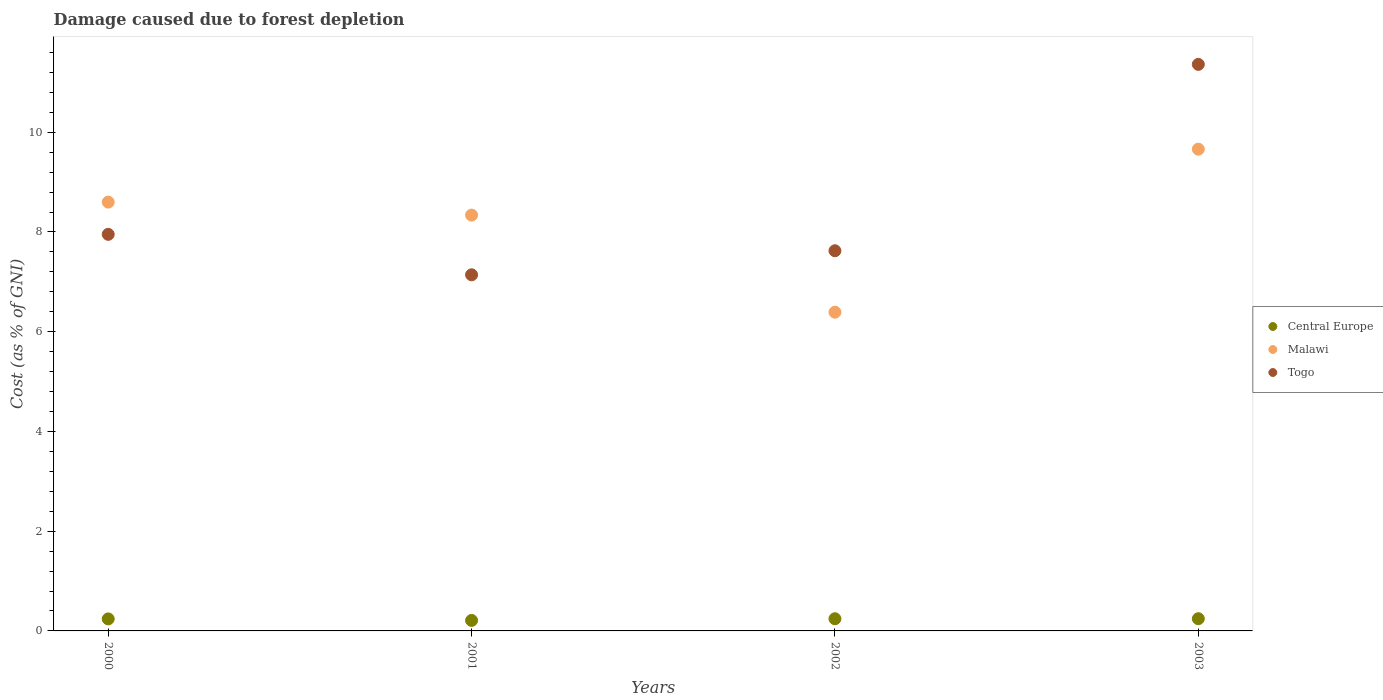Is the number of dotlines equal to the number of legend labels?
Your response must be concise. Yes. What is the cost of damage caused due to forest depletion in Central Europe in 2003?
Provide a succinct answer. 0.24. Across all years, what is the maximum cost of damage caused due to forest depletion in Togo?
Offer a very short reply. 11.36. Across all years, what is the minimum cost of damage caused due to forest depletion in Togo?
Make the answer very short. 7.14. In which year was the cost of damage caused due to forest depletion in Togo maximum?
Provide a succinct answer. 2003. What is the total cost of damage caused due to forest depletion in Malawi in the graph?
Ensure brevity in your answer.  32.99. What is the difference between the cost of damage caused due to forest depletion in Malawi in 2002 and that in 2003?
Offer a terse response. -3.27. What is the difference between the cost of damage caused due to forest depletion in Togo in 2003 and the cost of damage caused due to forest depletion in Central Europe in 2001?
Ensure brevity in your answer.  11.15. What is the average cost of damage caused due to forest depletion in Malawi per year?
Your answer should be compact. 8.25. In the year 2000, what is the difference between the cost of damage caused due to forest depletion in Malawi and cost of damage caused due to forest depletion in Central Europe?
Offer a terse response. 8.36. What is the ratio of the cost of damage caused due to forest depletion in Togo in 2000 to that in 2002?
Offer a terse response. 1.04. Is the difference between the cost of damage caused due to forest depletion in Malawi in 2000 and 2002 greater than the difference between the cost of damage caused due to forest depletion in Central Europe in 2000 and 2002?
Give a very brief answer. Yes. What is the difference between the highest and the second highest cost of damage caused due to forest depletion in Togo?
Your response must be concise. 3.41. What is the difference between the highest and the lowest cost of damage caused due to forest depletion in Togo?
Offer a very short reply. 4.22. In how many years, is the cost of damage caused due to forest depletion in Togo greater than the average cost of damage caused due to forest depletion in Togo taken over all years?
Provide a succinct answer. 1. Is the sum of the cost of damage caused due to forest depletion in Togo in 2002 and 2003 greater than the maximum cost of damage caused due to forest depletion in Malawi across all years?
Your answer should be very brief. Yes. Is the cost of damage caused due to forest depletion in Togo strictly greater than the cost of damage caused due to forest depletion in Malawi over the years?
Offer a terse response. No. Is the cost of damage caused due to forest depletion in Central Europe strictly less than the cost of damage caused due to forest depletion in Malawi over the years?
Provide a short and direct response. Yes. How many dotlines are there?
Your response must be concise. 3. How many years are there in the graph?
Your answer should be compact. 4. What is the difference between two consecutive major ticks on the Y-axis?
Ensure brevity in your answer.  2. Where does the legend appear in the graph?
Ensure brevity in your answer.  Center right. How many legend labels are there?
Make the answer very short. 3. How are the legend labels stacked?
Provide a short and direct response. Vertical. What is the title of the graph?
Keep it short and to the point. Damage caused due to forest depletion. What is the label or title of the Y-axis?
Your answer should be very brief. Cost (as % of GNI). What is the Cost (as % of GNI) of Central Europe in 2000?
Offer a terse response. 0.24. What is the Cost (as % of GNI) in Malawi in 2000?
Your answer should be very brief. 8.6. What is the Cost (as % of GNI) of Togo in 2000?
Provide a succinct answer. 7.95. What is the Cost (as % of GNI) in Central Europe in 2001?
Your answer should be very brief. 0.21. What is the Cost (as % of GNI) in Malawi in 2001?
Your answer should be very brief. 8.34. What is the Cost (as % of GNI) of Togo in 2001?
Your answer should be compact. 7.14. What is the Cost (as % of GNI) of Central Europe in 2002?
Ensure brevity in your answer.  0.24. What is the Cost (as % of GNI) of Malawi in 2002?
Provide a short and direct response. 6.39. What is the Cost (as % of GNI) in Togo in 2002?
Give a very brief answer. 7.62. What is the Cost (as % of GNI) of Central Europe in 2003?
Your response must be concise. 0.24. What is the Cost (as % of GNI) in Malawi in 2003?
Give a very brief answer. 9.66. What is the Cost (as % of GNI) of Togo in 2003?
Offer a terse response. 11.36. Across all years, what is the maximum Cost (as % of GNI) of Central Europe?
Provide a succinct answer. 0.24. Across all years, what is the maximum Cost (as % of GNI) of Malawi?
Provide a short and direct response. 9.66. Across all years, what is the maximum Cost (as % of GNI) of Togo?
Give a very brief answer. 11.36. Across all years, what is the minimum Cost (as % of GNI) in Central Europe?
Your answer should be compact. 0.21. Across all years, what is the minimum Cost (as % of GNI) in Malawi?
Ensure brevity in your answer.  6.39. Across all years, what is the minimum Cost (as % of GNI) of Togo?
Offer a very short reply. 7.14. What is the total Cost (as % of GNI) in Central Europe in the graph?
Give a very brief answer. 0.94. What is the total Cost (as % of GNI) of Malawi in the graph?
Your answer should be compact. 32.99. What is the total Cost (as % of GNI) of Togo in the graph?
Give a very brief answer. 34.08. What is the difference between the Cost (as % of GNI) in Central Europe in 2000 and that in 2001?
Your response must be concise. 0.03. What is the difference between the Cost (as % of GNI) in Malawi in 2000 and that in 2001?
Provide a succinct answer. 0.26. What is the difference between the Cost (as % of GNI) in Togo in 2000 and that in 2001?
Offer a very short reply. 0.81. What is the difference between the Cost (as % of GNI) of Central Europe in 2000 and that in 2002?
Provide a succinct answer. -0. What is the difference between the Cost (as % of GNI) of Malawi in 2000 and that in 2002?
Your answer should be very brief. 2.21. What is the difference between the Cost (as % of GNI) of Togo in 2000 and that in 2002?
Provide a succinct answer. 0.33. What is the difference between the Cost (as % of GNI) in Central Europe in 2000 and that in 2003?
Your response must be concise. -0. What is the difference between the Cost (as % of GNI) of Malawi in 2000 and that in 2003?
Provide a short and direct response. -1.06. What is the difference between the Cost (as % of GNI) in Togo in 2000 and that in 2003?
Offer a very short reply. -3.41. What is the difference between the Cost (as % of GNI) in Central Europe in 2001 and that in 2002?
Give a very brief answer. -0.03. What is the difference between the Cost (as % of GNI) in Malawi in 2001 and that in 2002?
Make the answer very short. 1.95. What is the difference between the Cost (as % of GNI) of Togo in 2001 and that in 2002?
Ensure brevity in your answer.  -0.48. What is the difference between the Cost (as % of GNI) of Central Europe in 2001 and that in 2003?
Make the answer very short. -0.03. What is the difference between the Cost (as % of GNI) in Malawi in 2001 and that in 2003?
Keep it short and to the point. -1.32. What is the difference between the Cost (as % of GNI) in Togo in 2001 and that in 2003?
Ensure brevity in your answer.  -4.22. What is the difference between the Cost (as % of GNI) in Central Europe in 2002 and that in 2003?
Your answer should be very brief. -0. What is the difference between the Cost (as % of GNI) in Malawi in 2002 and that in 2003?
Your answer should be compact. -3.27. What is the difference between the Cost (as % of GNI) of Togo in 2002 and that in 2003?
Keep it short and to the point. -3.74. What is the difference between the Cost (as % of GNI) of Central Europe in 2000 and the Cost (as % of GNI) of Malawi in 2001?
Provide a short and direct response. -8.1. What is the difference between the Cost (as % of GNI) of Central Europe in 2000 and the Cost (as % of GNI) of Togo in 2001?
Offer a very short reply. -6.9. What is the difference between the Cost (as % of GNI) of Malawi in 2000 and the Cost (as % of GNI) of Togo in 2001?
Your answer should be very brief. 1.46. What is the difference between the Cost (as % of GNI) of Central Europe in 2000 and the Cost (as % of GNI) of Malawi in 2002?
Offer a terse response. -6.15. What is the difference between the Cost (as % of GNI) in Central Europe in 2000 and the Cost (as % of GNI) in Togo in 2002?
Give a very brief answer. -7.38. What is the difference between the Cost (as % of GNI) in Malawi in 2000 and the Cost (as % of GNI) in Togo in 2002?
Offer a terse response. 0.98. What is the difference between the Cost (as % of GNI) of Central Europe in 2000 and the Cost (as % of GNI) of Malawi in 2003?
Offer a terse response. -9.42. What is the difference between the Cost (as % of GNI) in Central Europe in 2000 and the Cost (as % of GNI) in Togo in 2003?
Make the answer very short. -11.12. What is the difference between the Cost (as % of GNI) in Malawi in 2000 and the Cost (as % of GNI) in Togo in 2003?
Offer a very short reply. -2.76. What is the difference between the Cost (as % of GNI) in Central Europe in 2001 and the Cost (as % of GNI) in Malawi in 2002?
Keep it short and to the point. -6.18. What is the difference between the Cost (as % of GNI) of Central Europe in 2001 and the Cost (as % of GNI) of Togo in 2002?
Your answer should be compact. -7.41. What is the difference between the Cost (as % of GNI) of Malawi in 2001 and the Cost (as % of GNI) of Togo in 2002?
Ensure brevity in your answer.  0.72. What is the difference between the Cost (as % of GNI) of Central Europe in 2001 and the Cost (as % of GNI) of Malawi in 2003?
Give a very brief answer. -9.45. What is the difference between the Cost (as % of GNI) of Central Europe in 2001 and the Cost (as % of GNI) of Togo in 2003?
Ensure brevity in your answer.  -11.15. What is the difference between the Cost (as % of GNI) of Malawi in 2001 and the Cost (as % of GNI) of Togo in 2003?
Keep it short and to the point. -3.02. What is the difference between the Cost (as % of GNI) in Central Europe in 2002 and the Cost (as % of GNI) in Malawi in 2003?
Your answer should be very brief. -9.42. What is the difference between the Cost (as % of GNI) of Central Europe in 2002 and the Cost (as % of GNI) of Togo in 2003?
Give a very brief answer. -11.12. What is the difference between the Cost (as % of GNI) in Malawi in 2002 and the Cost (as % of GNI) in Togo in 2003?
Make the answer very short. -4.97. What is the average Cost (as % of GNI) of Central Europe per year?
Your answer should be very brief. 0.23. What is the average Cost (as % of GNI) of Malawi per year?
Offer a very short reply. 8.25. What is the average Cost (as % of GNI) of Togo per year?
Make the answer very short. 8.52. In the year 2000, what is the difference between the Cost (as % of GNI) of Central Europe and Cost (as % of GNI) of Malawi?
Give a very brief answer. -8.36. In the year 2000, what is the difference between the Cost (as % of GNI) in Central Europe and Cost (as % of GNI) in Togo?
Give a very brief answer. -7.71. In the year 2000, what is the difference between the Cost (as % of GNI) in Malawi and Cost (as % of GNI) in Togo?
Keep it short and to the point. 0.65. In the year 2001, what is the difference between the Cost (as % of GNI) in Central Europe and Cost (as % of GNI) in Malawi?
Your response must be concise. -8.13. In the year 2001, what is the difference between the Cost (as % of GNI) of Central Europe and Cost (as % of GNI) of Togo?
Make the answer very short. -6.93. In the year 2001, what is the difference between the Cost (as % of GNI) in Malawi and Cost (as % of GNI) in Togo?
Your answer should be very brief. 1.2. In the year 2002, what is the difference between the Cost (as % of GNI) in Central Europe and Cost (as % of GNI) in Malawi?
Make the answer very short. -6.15. In the year 2002, what is the difference between the Cost (as % of GNI) of Central Europe and Cost (as % of GNI) of Togo?
Your answer should be very brief. -7.38. In the year 2002, what is the difference between the Cost (as % of GNI) of Malawi and Cost (as % of GNI) of Togo?
Keep it short and to the point. -1.23. In the year 2003, what is the difference between the Cost (as % of GNI) in Central Europe and Cost (as % of GNI) in Malawi?
Your response must be concise. -9.42. In the year 2003, what is the difference between the Cost (as % of GNI) of Central Europe and Cost (as % of GNI) of Togo?
Give a very brief answer. -11.12. In the year 2003, what is the difference between the Cost (as % of GNI) of Malawi and Cost (as % of GNI) of Togo?
Your answer should be compact. -1.7. What is the ratio of the Cost (as % of GNI) of Central Europe in 2000 to that in 2001?
Ensure brevity in your answer.  1.14. What is the ratio of the Cost (as % of GNI) in Malawi in 2000 to that in 2001?
Provide a short and direct response. 1.03. What is the ratio of the Cost (as % of GNI) in Togo in 2000 to that in 2001?
Your response must be concise. 1.11. What is the ratio of the Cost (as % of GNI) of Central Europe in 2000 to that in 2002?
Offer a very short reply. 0.99. What is the ratio of the Cost (as % of GNI) of Malawi in 2000 to that in 2002?
Ensure brevity in your answer.  1.35. What is the ratio of the Cost (as % of GNI) in Togo in 2000 to that in 2002?
Keep it short and to the point. 1.04. What is the ratio of the Cost (as % of GNI) in Central Europe in 2000 to that in 2003?
Your answer should be very brief. 0.98. What is the ratio of the Cost (as % of GNI) of Malawi in 2000 to that in 2003?
Give a very brief answer. 0.89. What is the ratio of the Cost (as % of GNI) of Central Europe in 2001 to that in 2002?
Offer a very short reply. 0.86. What is the ratio of the Cost (as % of GNI) of Malawi in 2001 to that in 2002?
Provide a short and direct response. 1.3. What is the ratio of the Cost (as % of GNI) of Togo in 2001 to that in 2002?
Offer a very short reply. 0.94. What is the ratio of the Cost (as % of GNI) in Central Europe in 2001 to that in 2003?
Provide a succinct answer. 0.86. What is the ratio of the Cost (as % of GNI) of Malawi in 2001 to that in 2003?
Give a very brief answer. 0.86. What is the ratio of the Cost (as % of GNI) in Togo in 2001 to that in 2003?
Give a very brief answer. 0.63. What is the ratio of the Cost (as % of GNI) of Central Europe in 2002 to that in 2003?
Offer a very short reply. 1. What is the ratio of the Cost (as % of GNI) in Malawi in 2002 to that in 2003?
Your answer should be very brief. 0.66. What is the ratio of the Cost (as % of GNI) in Togo in 2002 to that in 2003?
Your answer should be compact. 0.67. What is the difference between the highest and the second highest Cost (as % of GNI) of Central Europe?
Make the answer very short. 0. What is the difference between the highest and the second highest Cost (as % of GNI) of Malawi?
Provide a short and direct response. 1.06. What is the difference between the highest and the second highest Cost (as % of GNI) in Togo?
Provide a short and direct response. 3.41. What is the difference between the highest and the lowest Cost (as % of GNI) of Central Europe?
Provide a succinct answer. 0.03. What is the difference between the highest and the lowest Cost (as % of GNI) of Malawi?
Offer a terse response. 3.27. What is the difference between the highest and the lowest Cost (as % of GNI) in Togo?
Offer a terse response. 4.22. 